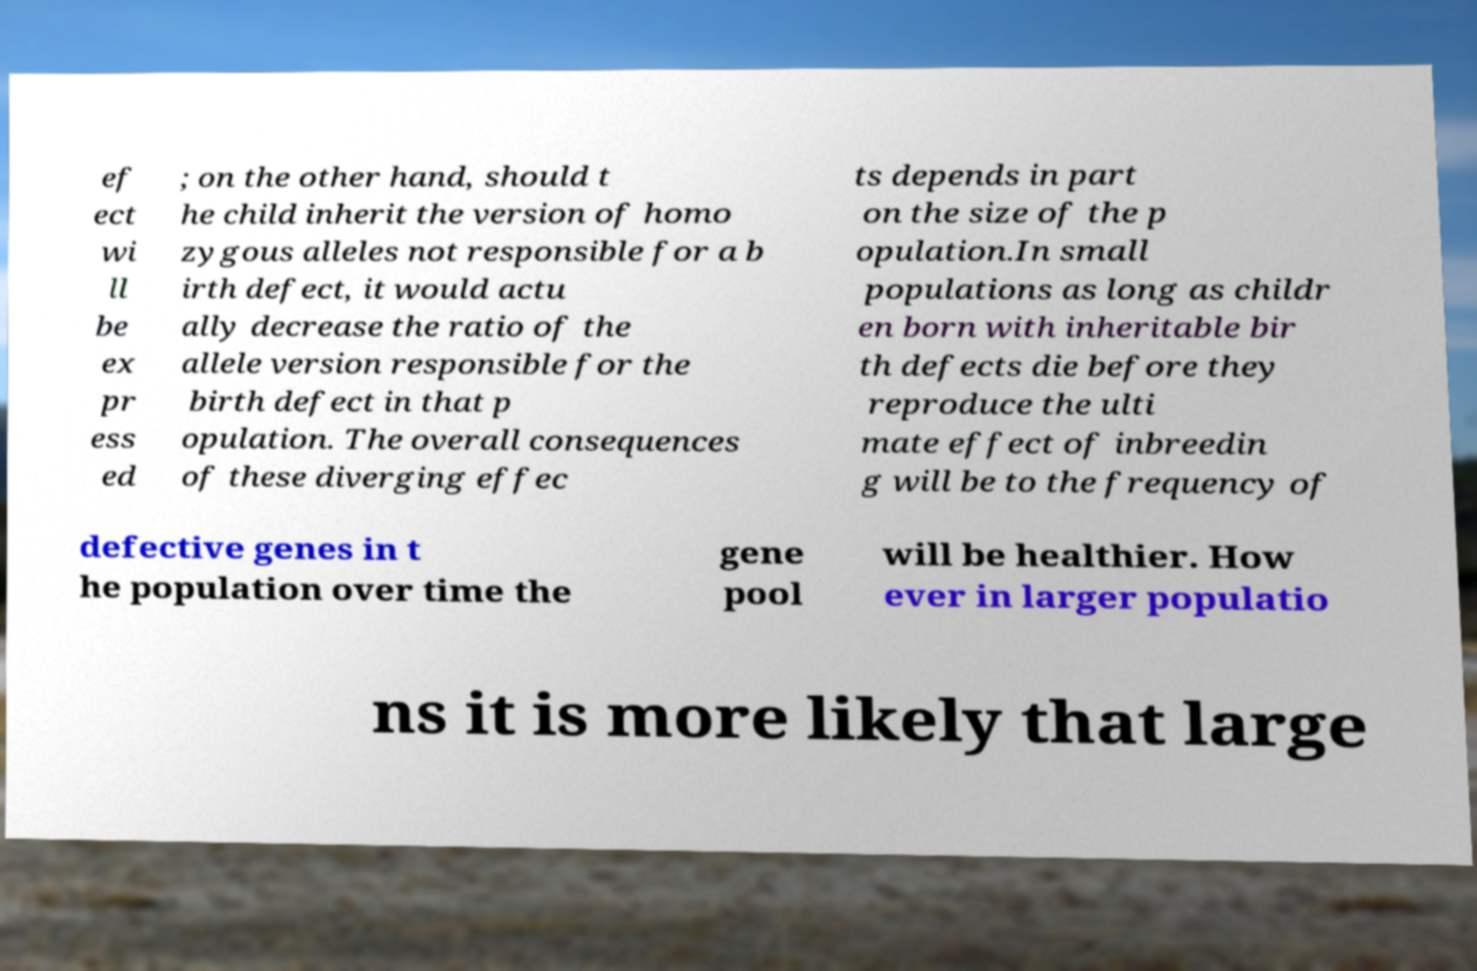Can you accurately transcribe the text from the provided image for me? ef ect wi ll be ex pr ess ed ; on the other hand, should t he child inherit the version of homo zygous alleles not responsible for a b irth defect, it would actu ally decrease the ratio of the allele version responsible for the birth defect in that p opulation. The overall consequences of these diverging effec ts depends in part on the size of the p opulation.In small populations as long as childr en born with inheritable bir th defects die before they reproduce the ulti mate effect of inbreedin g will be to the frequency of defective genes in t he population over time the gene pool will be healthier. How ever in larger populatio ns it is more likely that large 